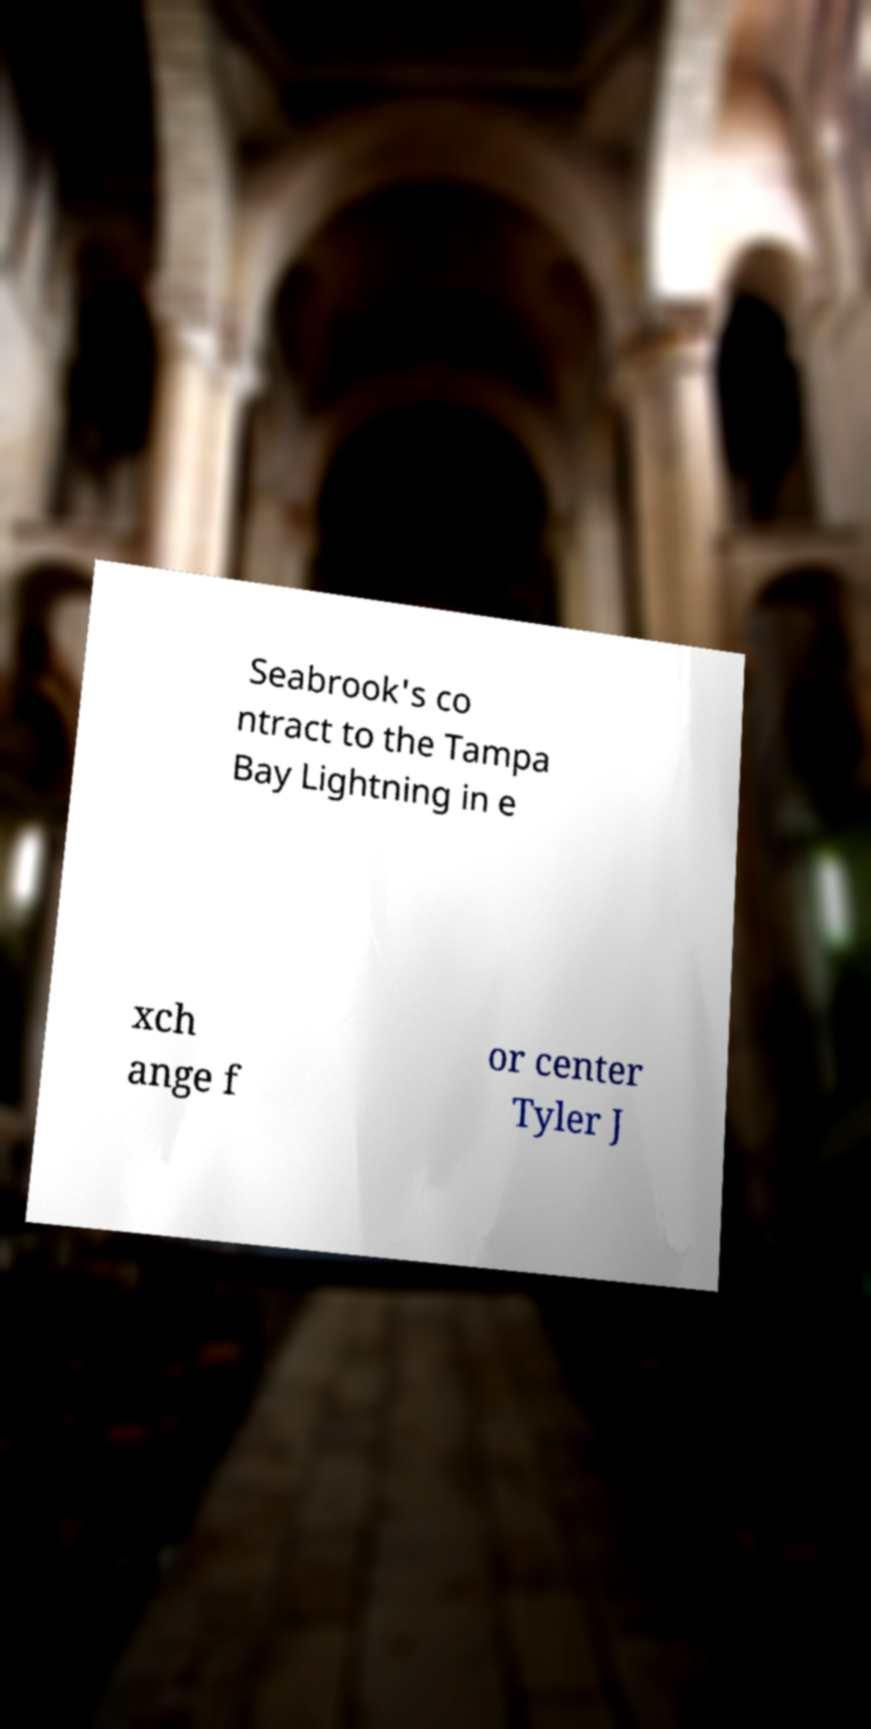Please read and relay the text visible in this image. What does it say? Seabrook's co ntract to the Tampa Bay Lightning in e xch ange f or center Tyler J 